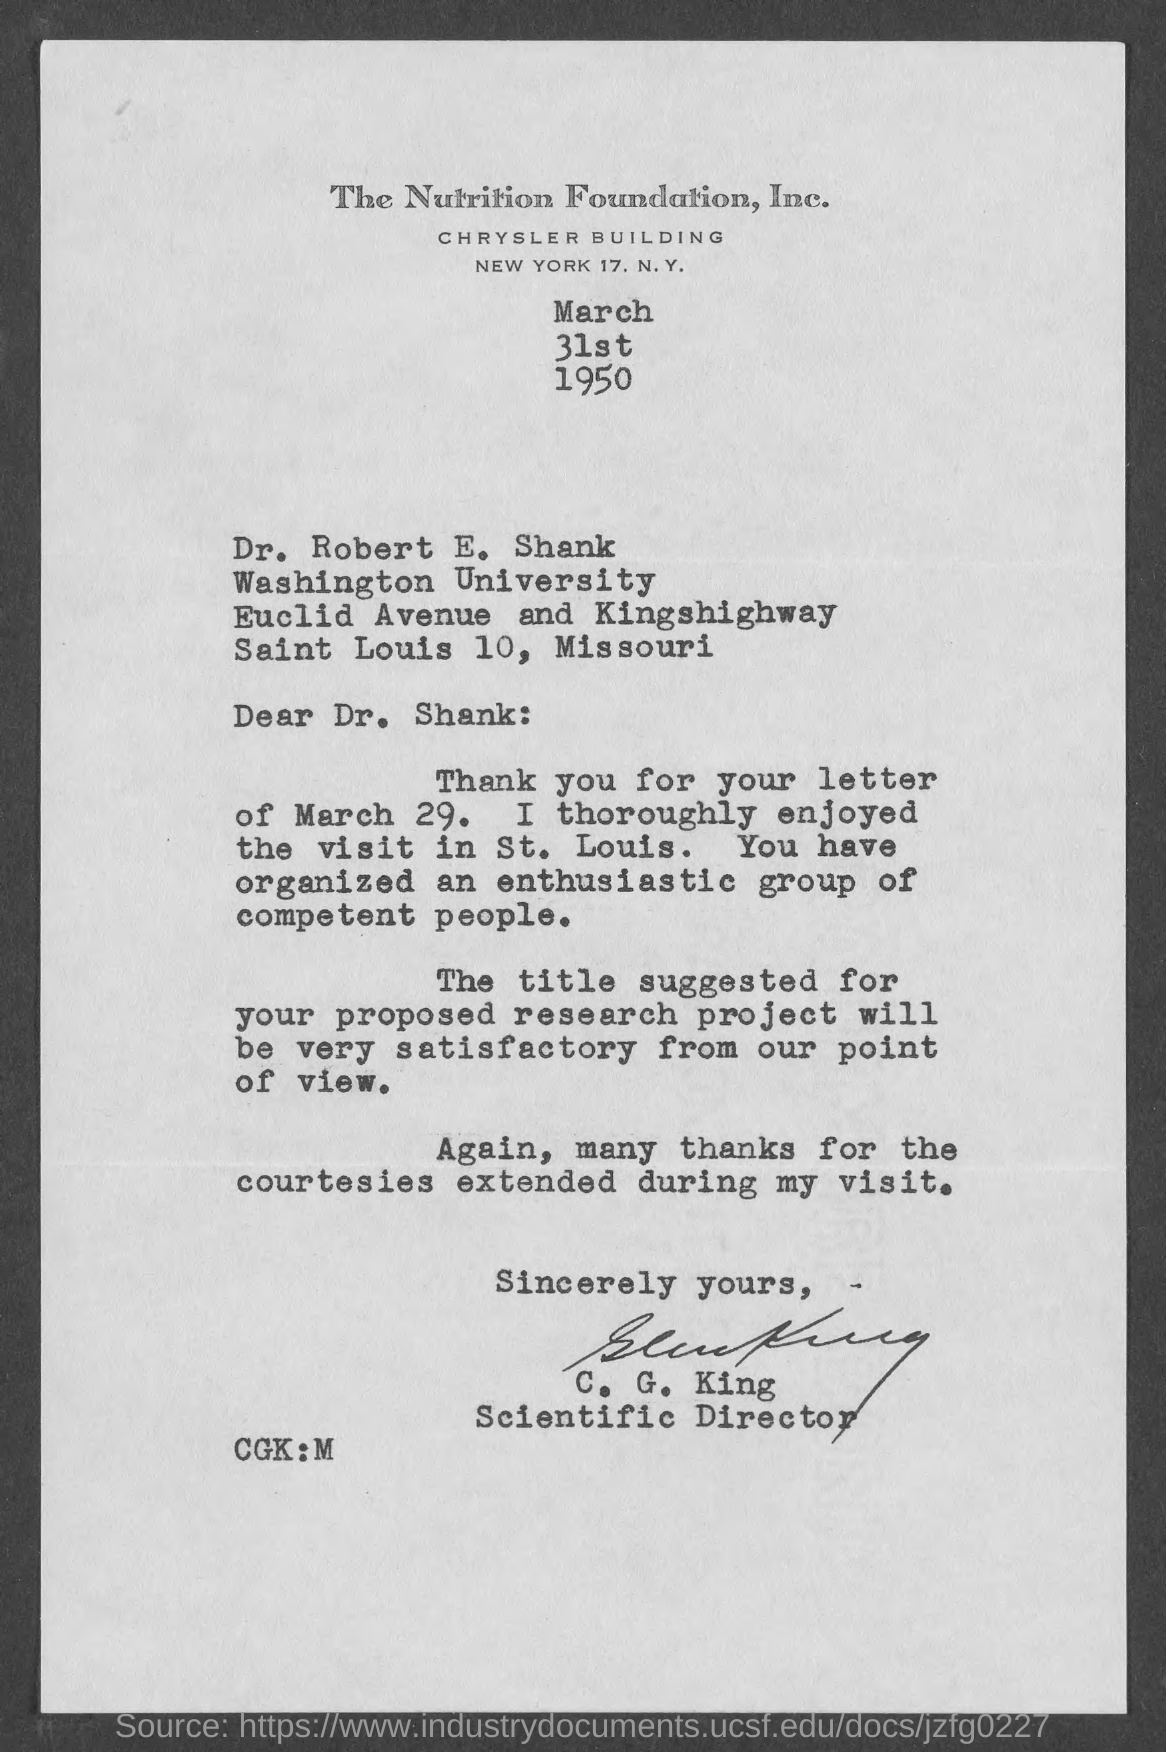Point out several critical features in this image. C.G. King is designated as the Scientific Director. Dr. Robert E. Shank is a member of Washington University. The date mentioned in the given letter is March 31st 1950. 